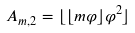<formula> <loc_0><loc_0><loc_500><loc_500>A _ { m , 2 } = \lfloor \lfloor m \varphi \rfloor \varphi ^ { 2 } \rfloor</formula> 